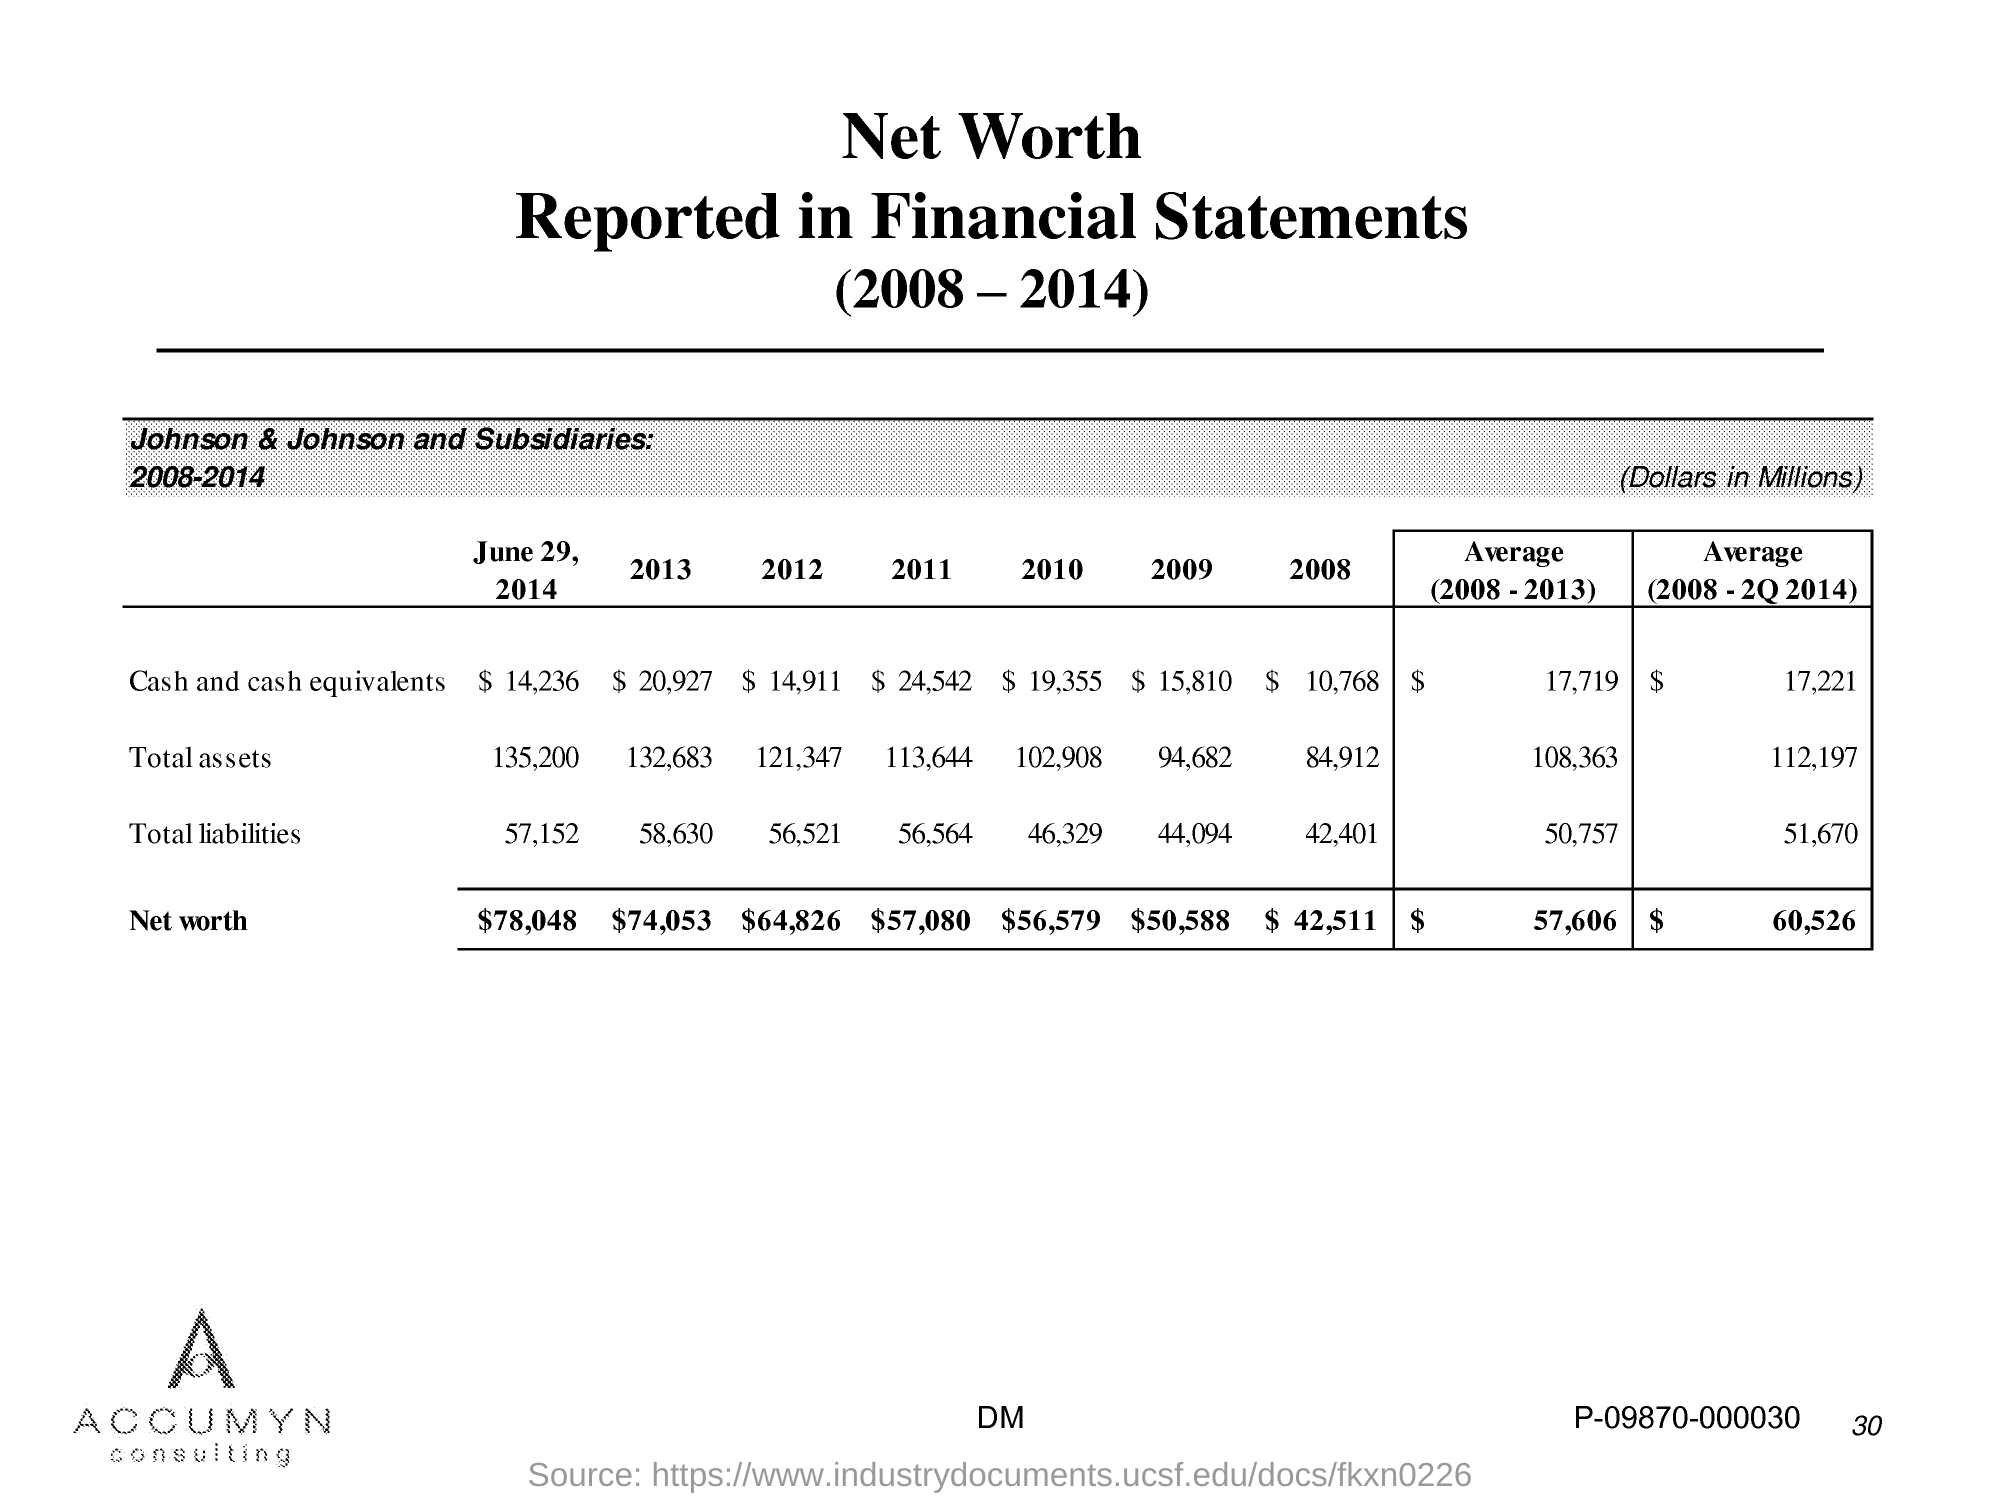Compare the average total assets from 2008-2013 with the average for 2008 - 2Q 2014, and discuss any significant observations. The average total assets for Johnson & Johnson from 2008-2013 were $108,363 million, while the average from 2008 - 2Q 2014 slightly increased to $112,197 million. This suggests a moderate growth in assets in the first half of 2014 compared to the previous average period. 